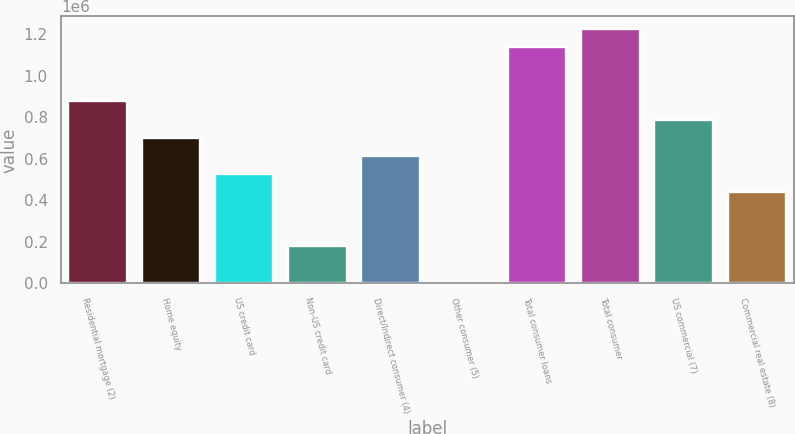Convert chart to OTSL. <chart><loc_0><loc_0><loc_500><loc_500><bar_chart><fcel>Residential mortgage (2)<fcel>Home equity<fcel>US credit card<fcel>Non-US credit card<fcel>Direct/Indirect consumer (4)<fcel>Other consumer (5)<fcel>Total consumer loans<fcel>Total consumer<fcel>US commercial (7)<fcel>Commercial real estate (8)<nl><fcel>876344<fcel>701909<fcel>527474<fcel>178605<fcel>614692<fcel>4170<fcel>1.138e+06<fcel>1.22521e+06<fcel>789127<fcel>440257<nl></chart> 